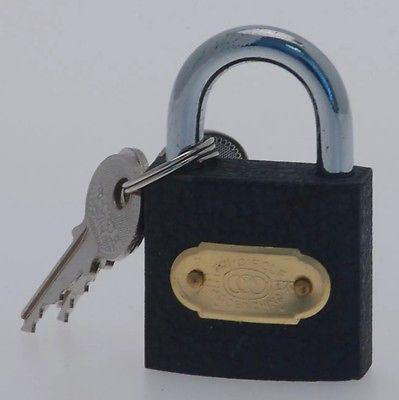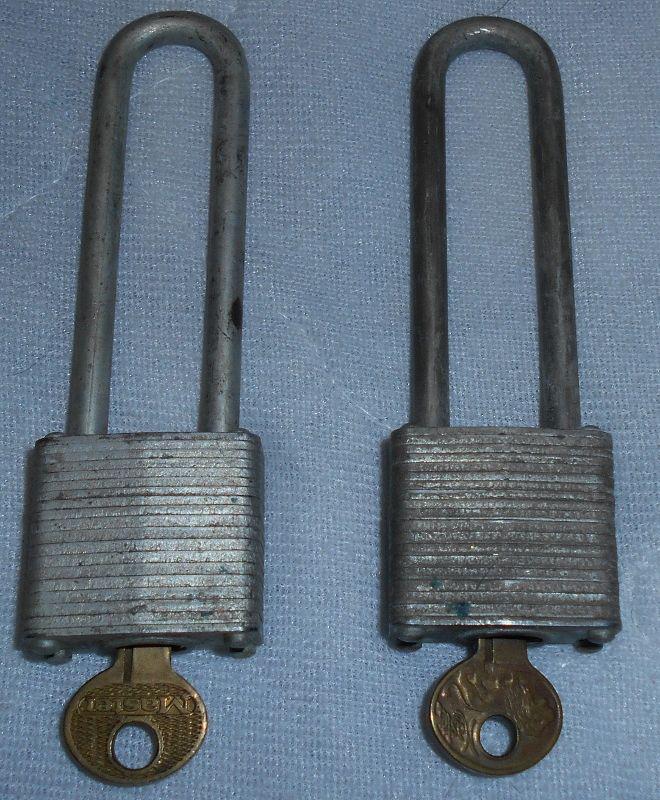The first image is the image on the left, the second image is the image on the right. Assess this claim about the two images: "there are locks with the keys inserted in the bottom". Correct or not? Answer yes or no. Yes. The first image is the image on the left, the second image is the image on the right. For the images shown, is this caption "There are no less than two keys inserted into padlocks" true? Answer yes or no. Yes. 